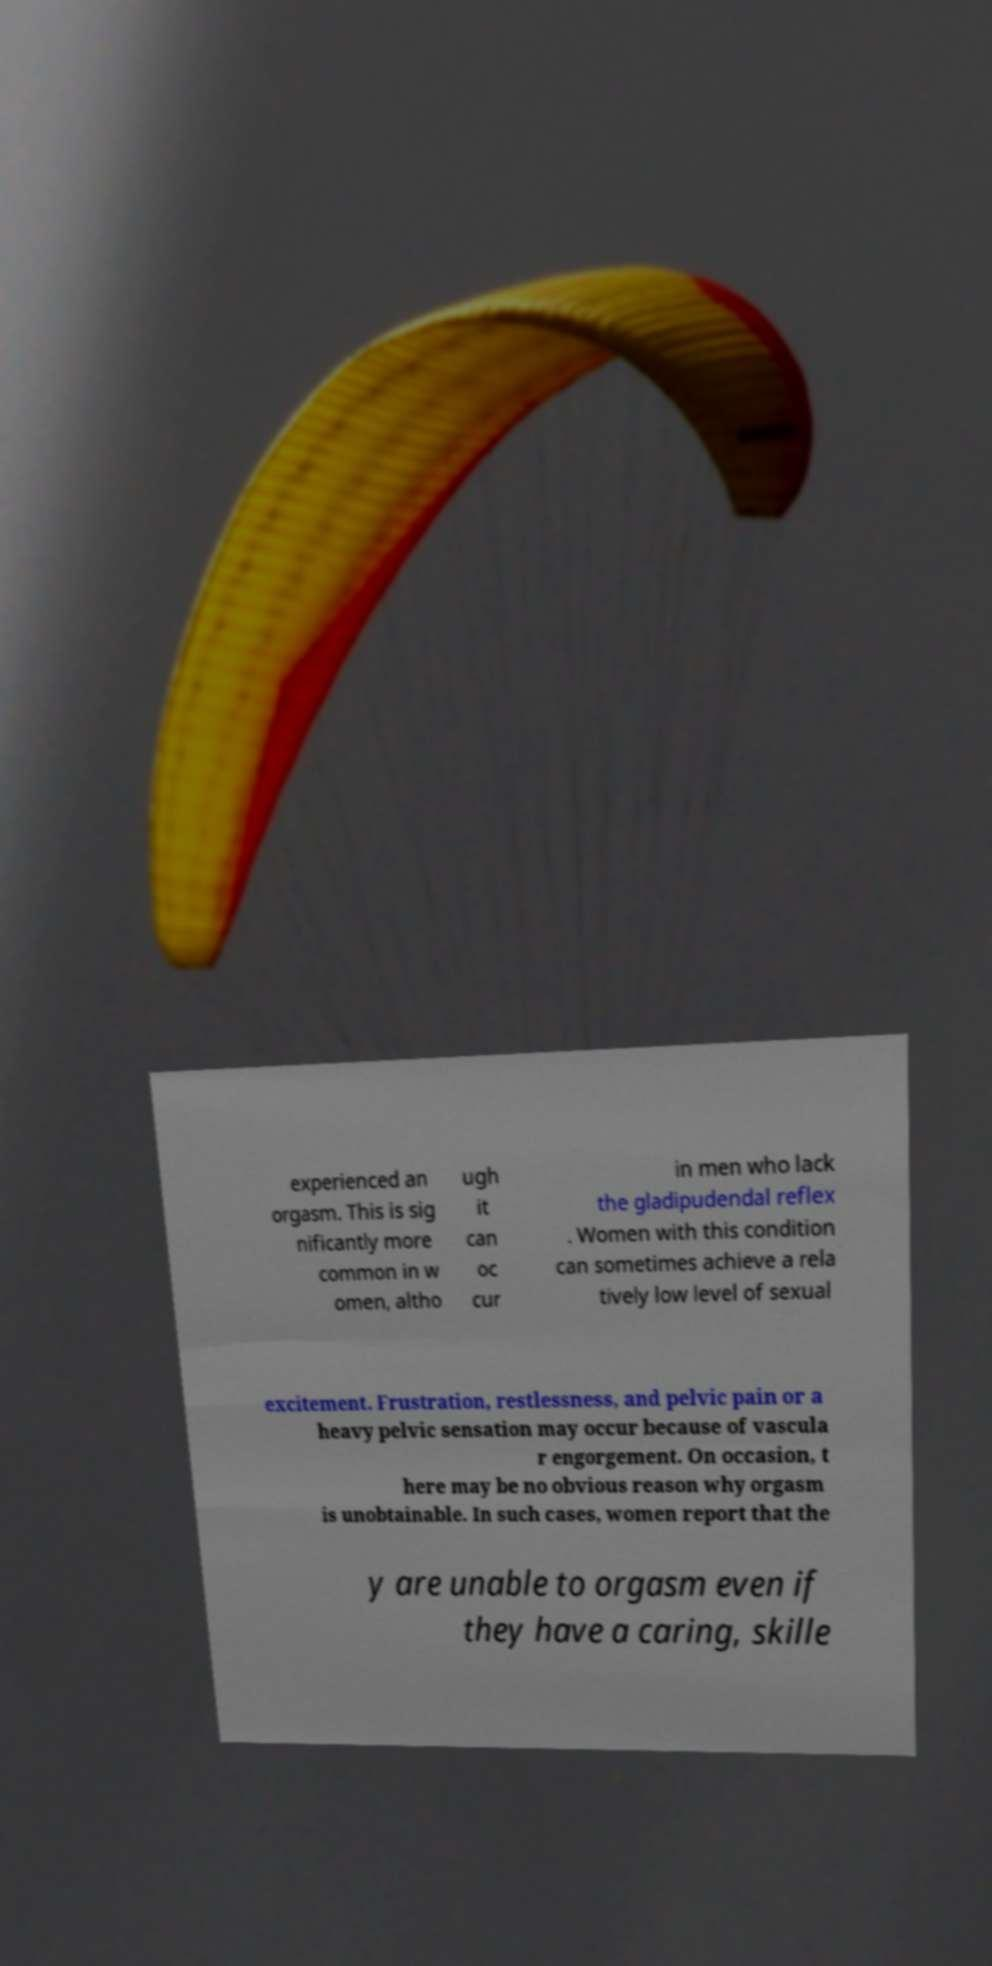There's text embedded in this image that I need extracted. Can you transcribe it verbatim? experienced an orgasm. This is sig nificantly more common in w omen, altho ugh it can oc cur in men who lack the gladipudendal reflex . Women with this condition can sometimes achieve a rela tively low level of sexual excitement. Frustration, restlessness, and pelvic pain or a heavy pelvic sensation may occur because of vascula r engorgement. On occasion, t here may be no obvious reason why orgasm is unobtainable. In such cases, women report that the y are unable to orgasm even if they have a caring, skille 